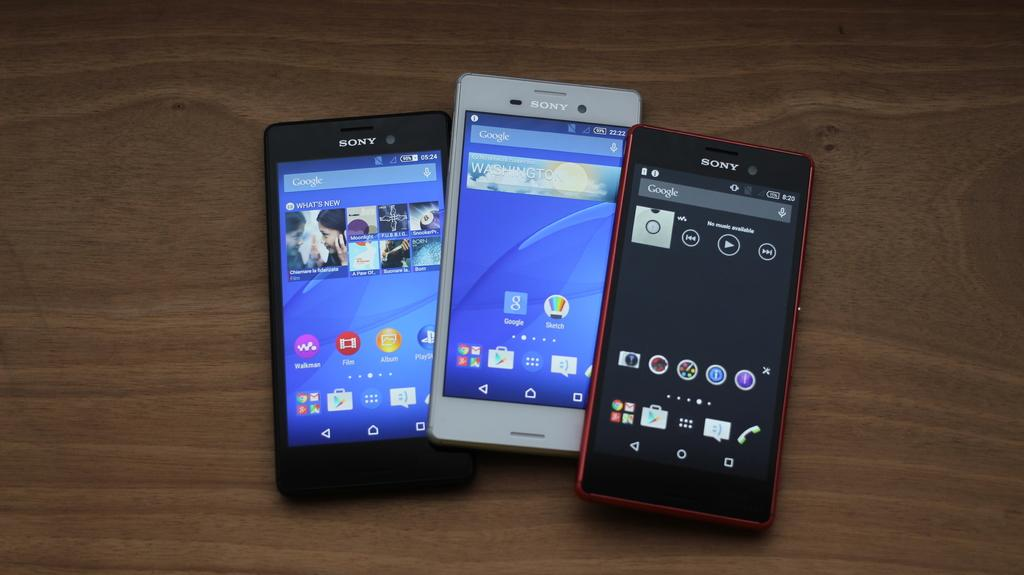<image>
Offer a succinct explanation of the picture presented. Three different Sony smart phones on a table. 